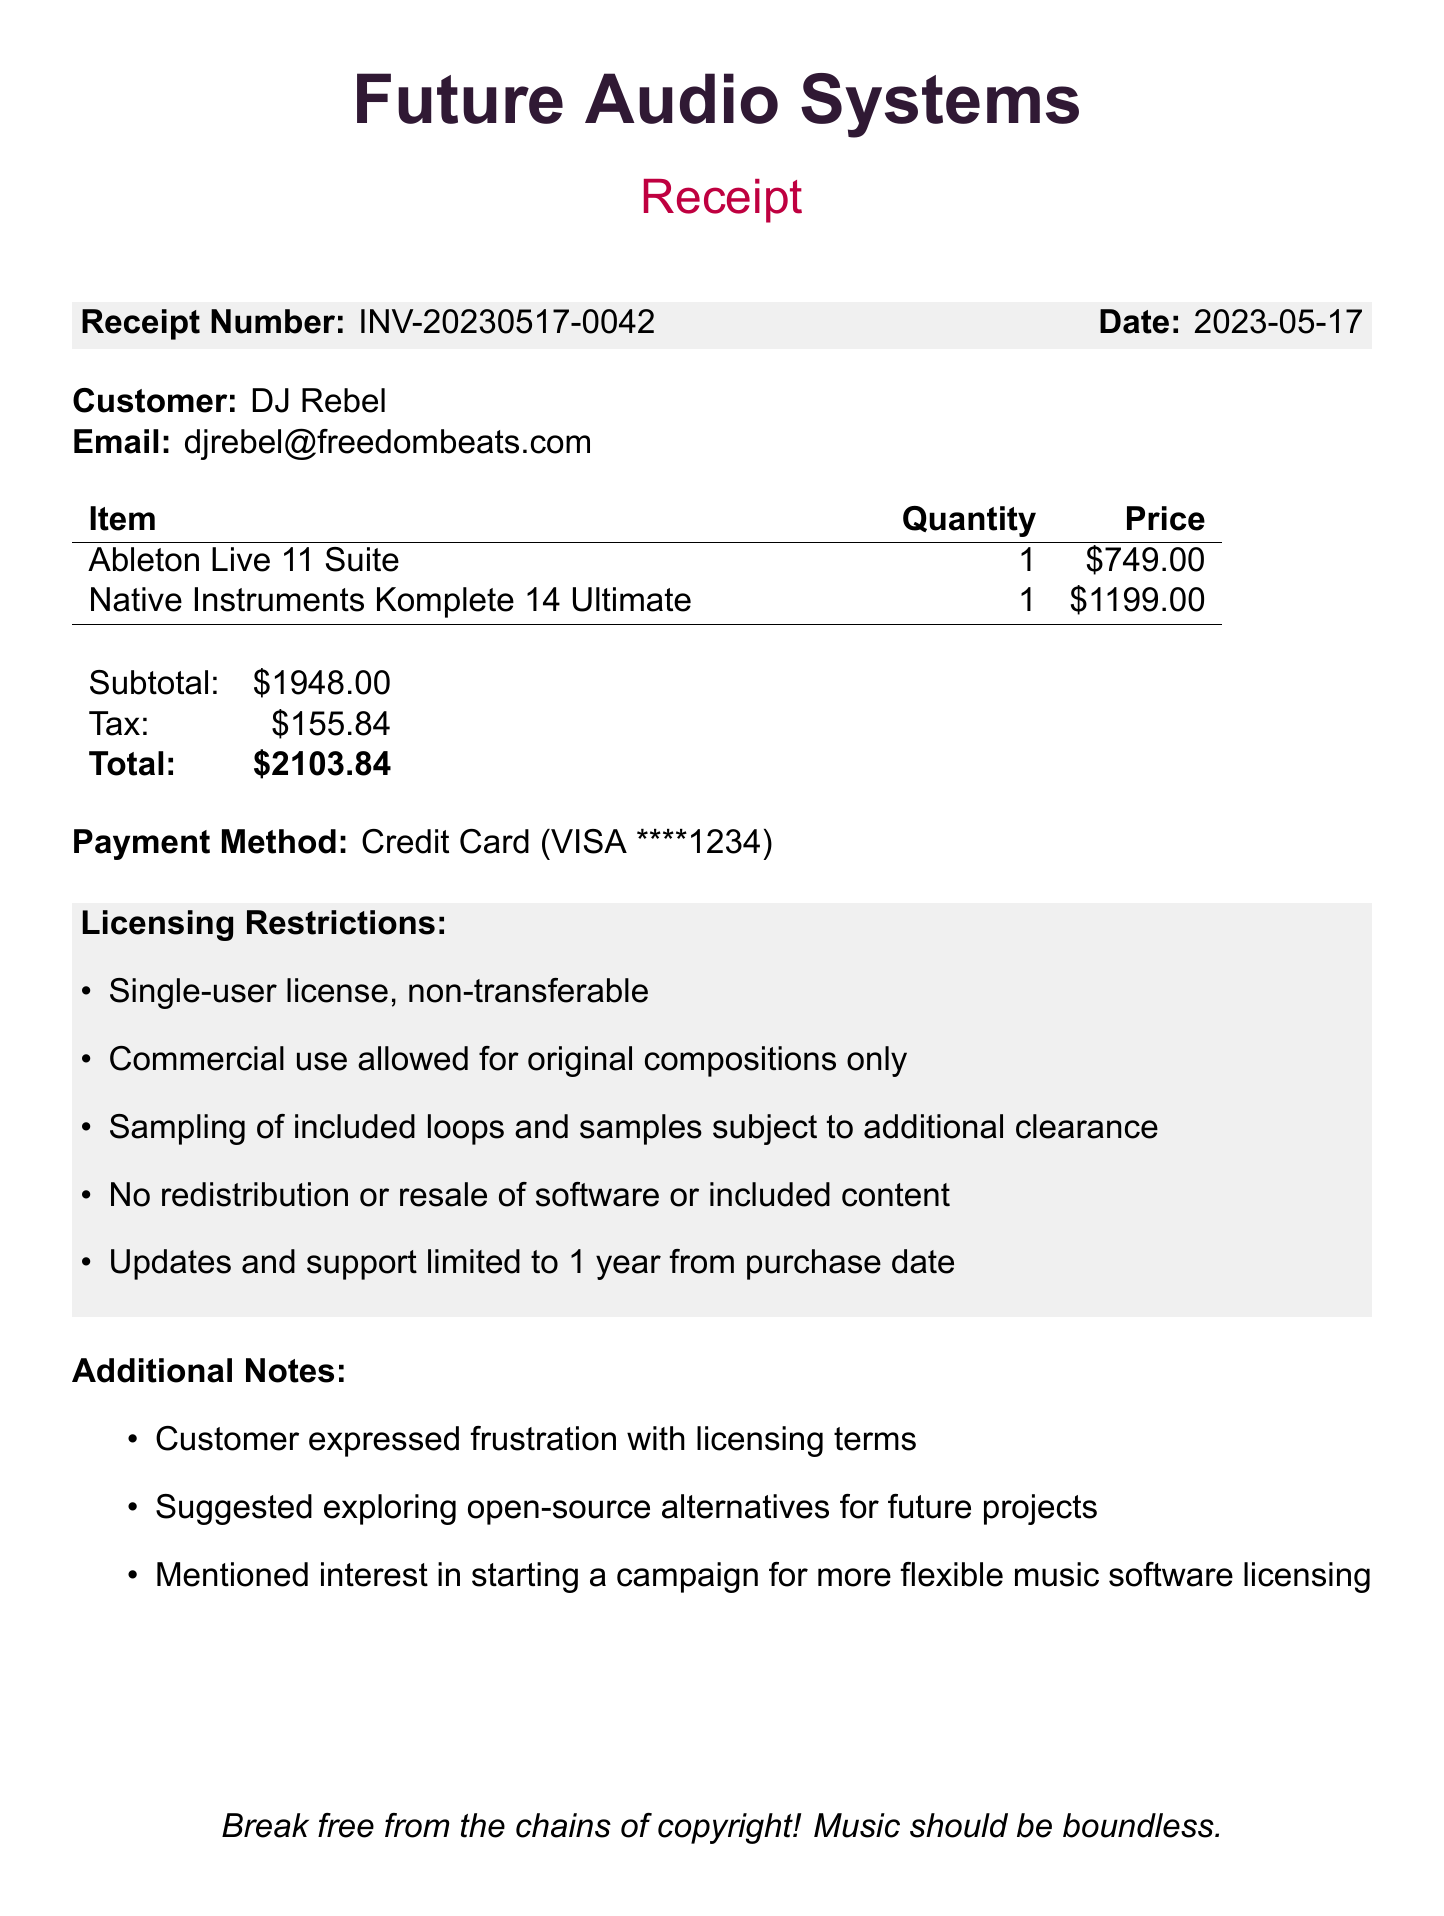What is the receipt number? The receipt number is provided for reference in the document, which is INV-20230517-0042.
Answer: INV-20230517-0042 What is the total amount paid? The total amount paid is the sum of the subtotal and tax, which is $2103.84.
Answer: $2103.84 Who is the customer? The customer's name is explicitly mentioned in the document as DJ Rebel.
Answer: DJ Rebel What payment method was used? The payment method is specifically noted in the document, which is a credit card payment with a VISA ending in 1234.
Answer: Credit Card (VISA ****1234) How many software items were purchased? The document lists two software items, specifically Ableton Live 11 Suite and Native Instruments Komplete 14 Ultimate.
Answer: 2 What are the licensing restrictions regarding commercial use? The commercial use is restricted to original compositions only, as outlined in the licensing section.
Answer: Original compositions only What additional notes did the customer express? The customer expressed frustration with licensing terms, which is noted in the additional notes section.
Answer: Frustration with licensing terms What does the customer suggest for future projects? The customer suggests exploring open-source alternatives for future projects, which is mentioned in the additional notes.
Answer: Open-source alternatives What is the tax amount? The tax amount is specifically listed in the document as $155.84.
Answer: $155.84 